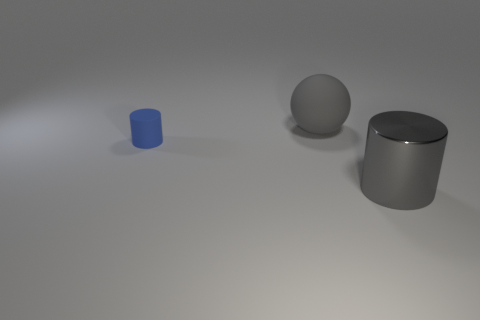Add 3 large metallic things. How many objects exist? 6 Subtract all cylinders. How many objects are left? 1 Subtract 0 brown blocks. How many objects are left? 3 Subtract all gray objects. Subtract all matte cylinders. How many objects are left? 0 Add 3 small blue matte cylinders. How many small blue matte cylinders are left? 4 Add 2 gray matte things. How many gray matte things exist? 3 